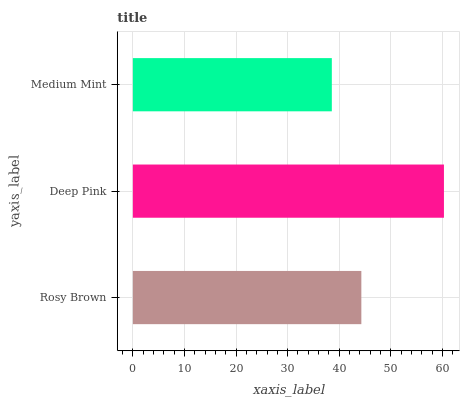Is Medium Mint the minimum?
Answer yes or no. Yes. Is Deep Pink the maximum?
Answer yes or no. Yes. Is Deep Pink the minimum?
Answer yes or no. No. Is Medium Mint the maximum?
Answer yes or no. No. Is Deep Pink greater than Medium Mint?
Answer yes or no. Yes. Is Medium Mint less than Deep Pink?
Answer yes or no. Yes. Is Medium Mint greater than Deep Pink?
Answer yes or no. No. Is Deep Pink less than Medium Mint?
Answer yes or no. No. Is Rosy Brown the high median?
Answer yes or no. Yes. Is Rosy Brown the low median?
Answer yes or no. Yes. Is Medium Mint the high median?
Answer yes or no. No. Is Deep Pink the low median?
Answer yes or no. No. 